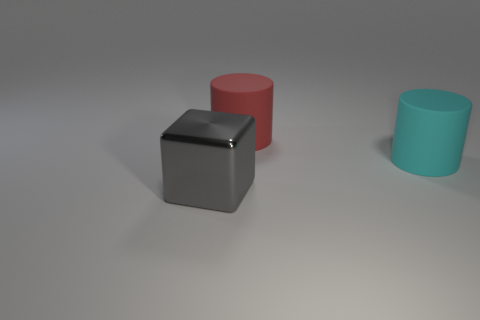Subtract 1 cylinders. How many cylinders are left? 1 Add 2 gray metal cubes. How many objects exist? 5 Subtract all brown cylinders. How many blue cubes are left? 0 Add 2 big cyan cylinders. How many big cyan cylinders exist? 3 Subtract all cyan cylinders. How many cylinders are left? 1 Subtract 0 brown cylinders. How many objects are left? 3 Subtract all cylinders. How many objects are left? 1 Subtract all cyan cylinders. Subtract all brown balls. How many cylinders are left? 1 Subtract all gray objects. Subtract all small cylinders. How many objects are left? 2 Add 2 large rubber objects. How many large rubber objects are left? 4 